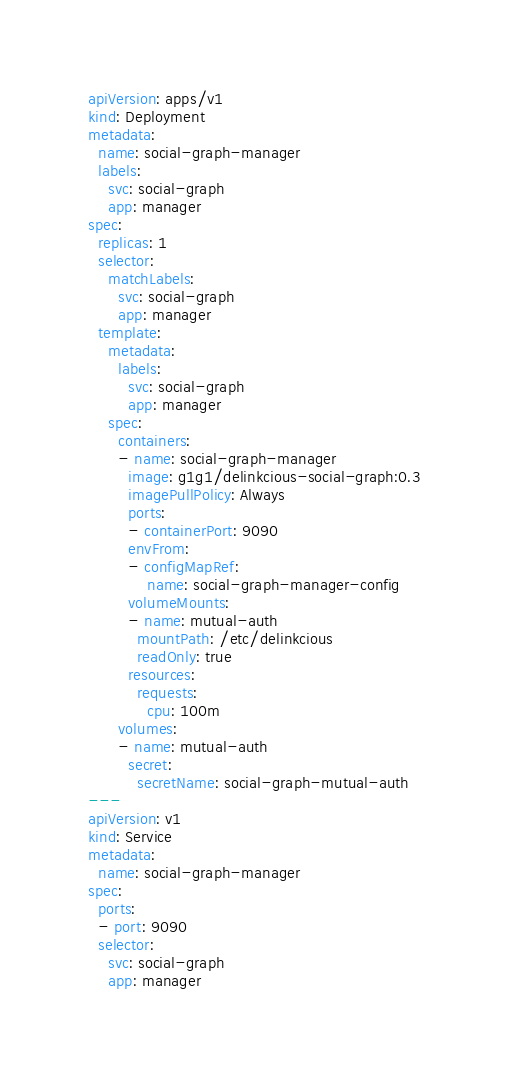<code> <loc_0><loc_0><loc_500><loc_500><_YAML_>apiVersion: apps/v1
kind: Deployment
metadata:
  name: social-graph-manager
  labels:
    svc: social-graph
    app: manager
spec:
  replicas: 1
  selector:
    matchLabels:
      svc: social-graph
      app: manager
  template:
    metadata:
      labels:
        svc: social-graph
        app: manager
    spec:
      containers:
      - name: social-graph-manager
        image: g1g1/delinkcious-social-graph:0.3
        imagePullPolicy: Always
        ports:
        - containerPort: 9090
        envFrom:
        - configMapRef:
            name: social-graph-manager-config
        volumeMounts:
        - name: mutual-auth
          mountPath: /etc/delinkcious
          readOnly: true
        resources:
          requests:
            cpu: 100m
      volumes:
      - name: mutual-auth
        secret:
          secretName: social-graph-mutual-auth
---
apiVersion: v1
kind: Service
metadata:
  name: social-graph-manager
spec:
  ports:
  - port: 9090
  selector:
    svc: social-graph
    app: manager
</code> 